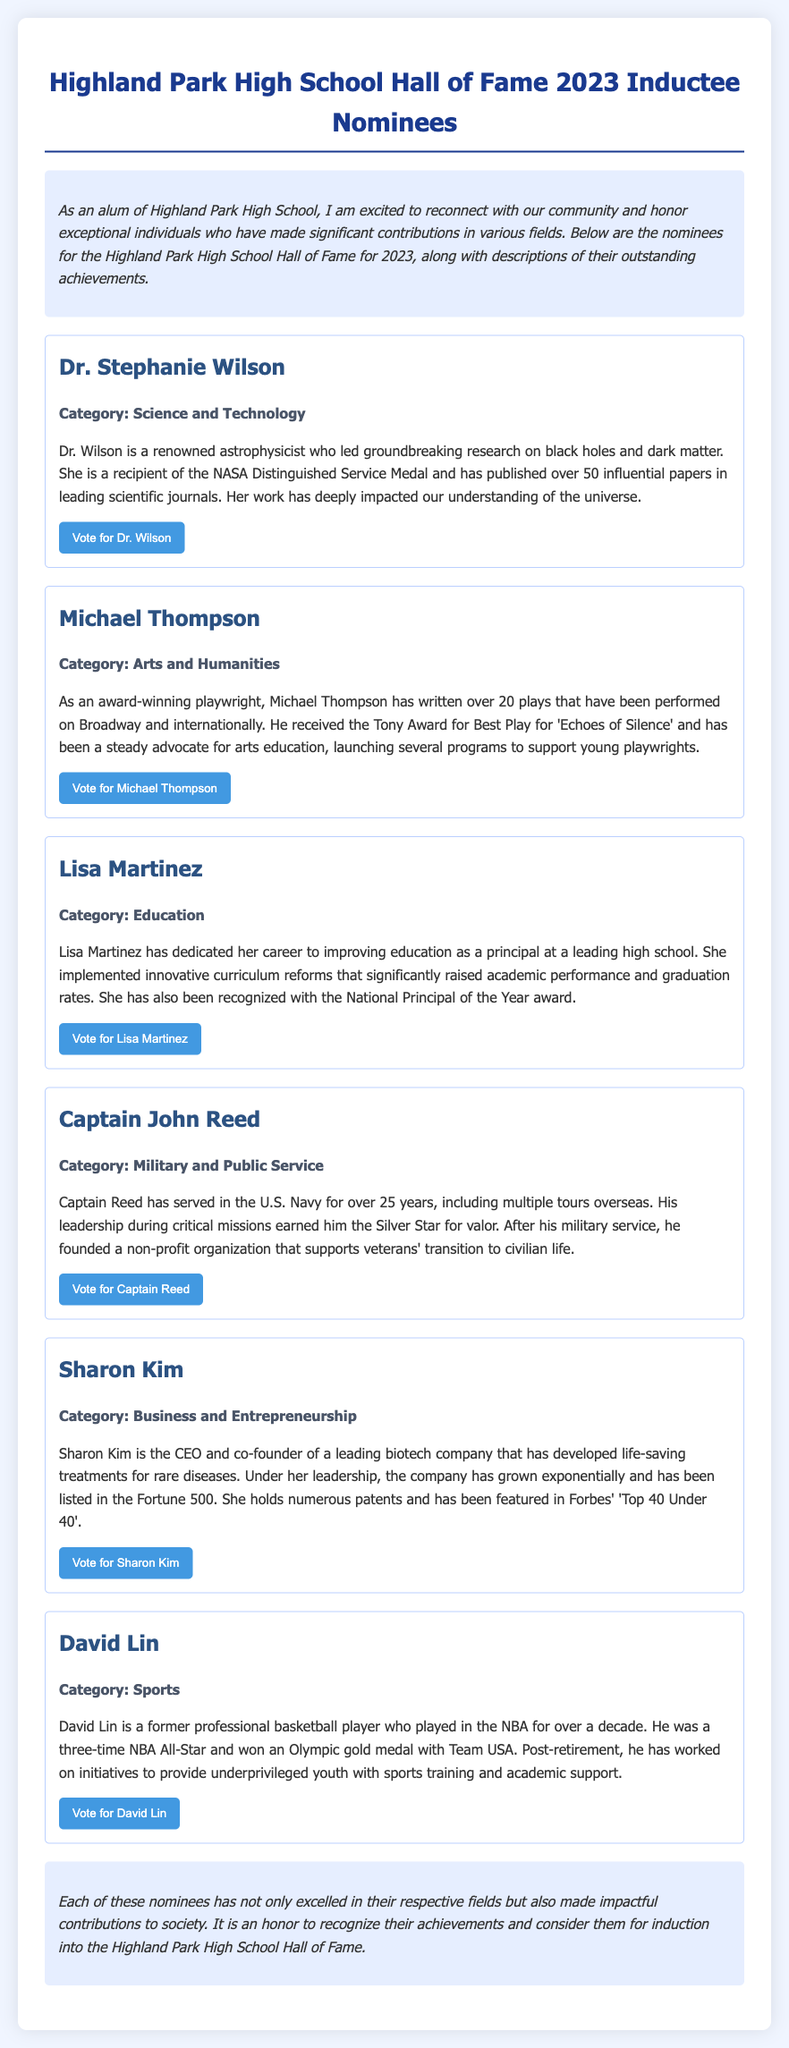What is Dr. Stephanie Wilson's category? Dr. Wilson is nominated in the category of Science and Technology, as stated in her nominee description.
Answer: Science and Technology How many papers has Dr. Wilson published? The document mentions that Dr. Wilson has published over 50 influential papers in leading scientific journals.
Answer: Over 50 What award did Michael Thompson receive? It is stated that Michael Thompson received the Tony Award for Best Play for 'Echoes of Silence'.
Answer: Tony Award What is Captain John Reed's military service duration? The document specifies that Captain Reed has served in the U.S. Navy for over 25 years.
Answer: Over 25 years Which company did Sharon Kim co-found? The document states that Sharon Kim is the CEO and co-founder of a leading biotech company.
Answer: Leading biotech company What is David Lin's Olympic achievement? It mentions that David Lin won an Olympic gold medal with Team USA during his career as a professional basketball player.
Answer: Olympic gold medal What is the main focus of Lisa Martinez's educational reforms? The document describes that she implemented innovative curriculum reforms that significantly raised academic performance and graduation rates.
Answer: Academic performance and graduation rates What is the purpose of Captain Reed's non-profit organization? According to the document, Captain Reed founded a non-profit organization that supports veterans' transition to civilian life.
Answer: Support veterans' transition to civilian life 